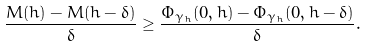<formula> <loc_0><loc_0><loc_500><loc_500>\frac { M ( h ) - M ( h - \delta ) } { \delta } & \geq \frac { \Phi _ { \gamma _ { h } } ( 0 , h ) - \Phi _ { \gamma _ { h } } ( 0 , h - \delta ) } { \delta } .</formula> 